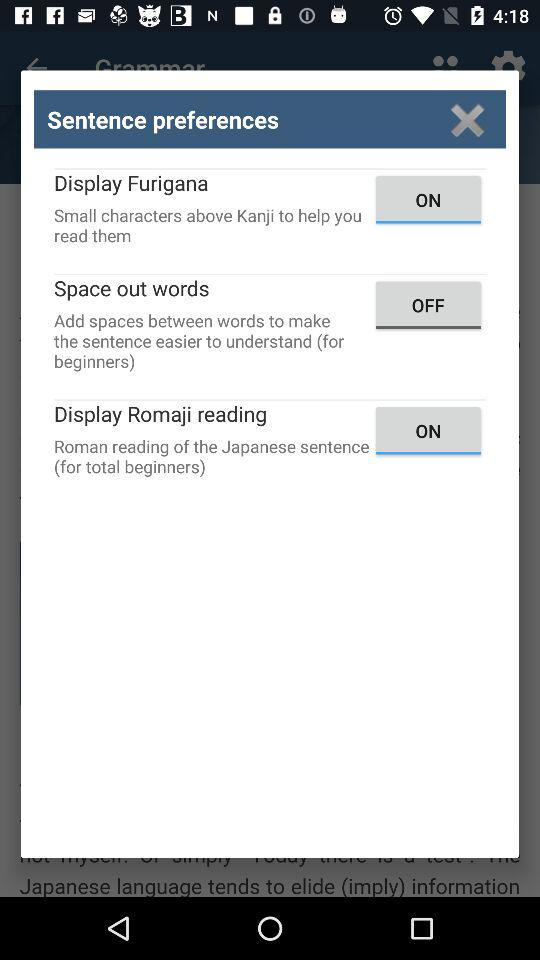How many options are available to make reading sentences easier?
Answer the question using a single word or phrase. 3 